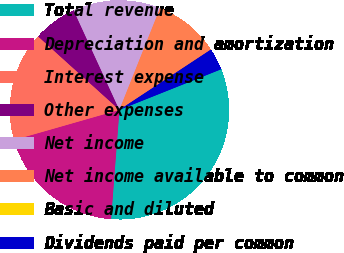Convert chart. <chart><loc_0><loc_0><loc_500><loc_500><pie_chart><fcel>Total revenue<fcel>Depreciation and amortization<fcel>Interest expense<fcel>Other expenses<fcel>Net income<fcel>Net income available to common<fcel>Basic and diluted<fcel>Dividends paid per common<nl><fcel>32.26%<fcel>19.35%<fcel>16.13%<fcel>6.45%<fcel>12.9%<fcel>9.68%<fcel>0.0%<fcel>3.23%<nl></chart> 